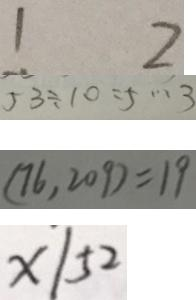Convert formula to latex. <formula><loc_0><loc_0><loc_500><loc_500>1 2 
 5 3 \div 1 0 = 5 \cdots 3 
 ( 7 6 , 2 0 9 ) = 1 9 
 x / 5 2</formula> 